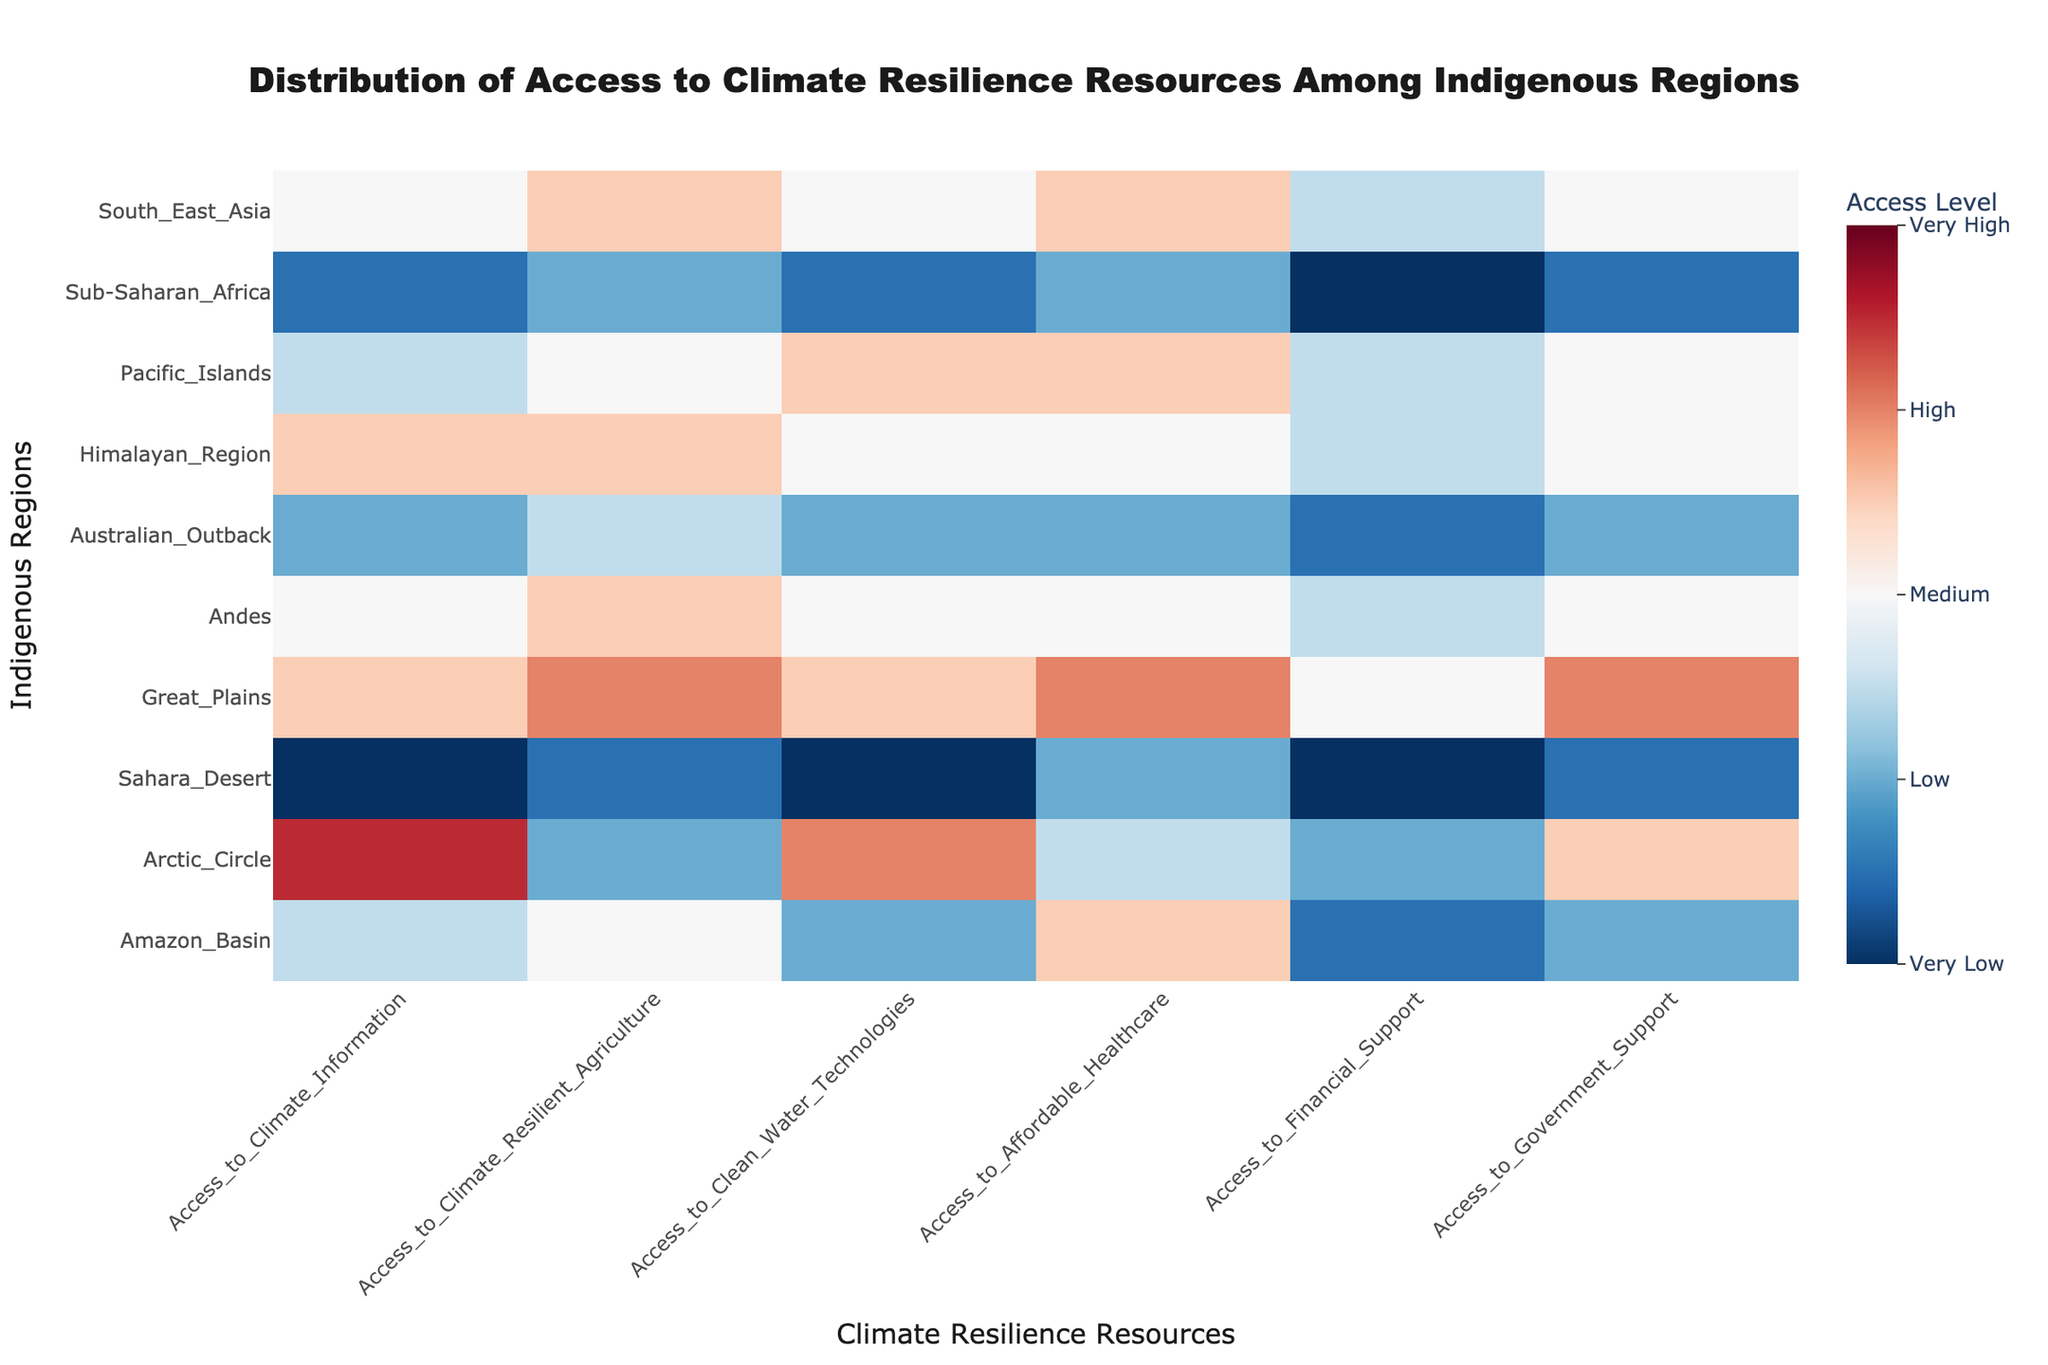What is the title of the heatmap? The title is located at the top center of the heatmap and reads "Distribution of Access to Climate Resilience Resources Among Indigenous Regions".
Answer: Distribution of Access to Climate Resilience Resources Among Indigenous Regions Which region has the highest access to Climate Information? The highest access level to Climate Information is represented by the darkest red color. The Arctic Circle region shows a value of 4.5, the highest on the heatmap.
Answer: Arctic Circle Which regions have very low access to Clean Water Technologies? Very low access is represented by the darkest blue color. The regions Sahara Desert and Sub-Saharan Africa have a value of 1.0 and 1.5 respectively in Clean Water Technologies.
Answer: Sahara Desert, Sub-Saharan Africa What is the access level of Affordable Healthcare for the Great Plains region? The access level for Affordable Healthcare in Great Plains is represented by the color corresponding to the value of 4.0, as observed in the heatmap.
Answer: 4.0 Which climate resilience resource does the Amazon Basin have the highest access to? To find this, look across the row for Amazon Basin. The highest value is 3.5, which corresponds to Affordable Healthcare.
Answer: Affordable Healthcare Compare the access to Financial Support between the Amazon Basin and the Great Plains. The Amazon Basin has an access level of 1.5 in Financial Support, while the Great Plains has a level of 3.0. The Great Plains have a higher access level.
Answer: Great Plains What is the average access level to Government Support across all regions? Add the access levels to Government Support for all regions and divide by the number of regions. (2.0 + 3.5 + 1.5 + 4.0 + 3.0 + 2.0 + 3.0 + 3.0 + 1.5 + 3.0) / 10 = 2.65.
Answer: 2.65 Which region has the highest overall average access across all resources? Calculate the average access for each region across all resources and compare them: 
Amazon Basin: 2.58,
Arctic Circle: 3.08,
Sahara Desert: 1.33,
Great Plains: 3.75,
Andes: 3.00,
Australian Outback: 2.00,
Himalayan Region: 3.08,
Pacific Islands: 3.00,
Sub-Saharan Africa: 1.75,
South East Asia: 3.08. Great Plains has the highest average access.
Answer: Great Plains Which regions show the lowest access to Financial Support? The regions with the lowest access to Financial Support are those with the darkest blue colors: Sahara Desert and Sub-Saharan Africa, both with an access level of 1.0.
Answer: Sahara Desert, Sub-Saharan Africa Compare the access levels to Government Support for the Arctic Circle and the Australian Outback. The Arctic Circle has a Government Support access level of 3.5, whereas the Australian Outback has a level of 2.0. The Arctic Circle has higher access compared to the Australian Outback.
Answer: Arctic Circle 